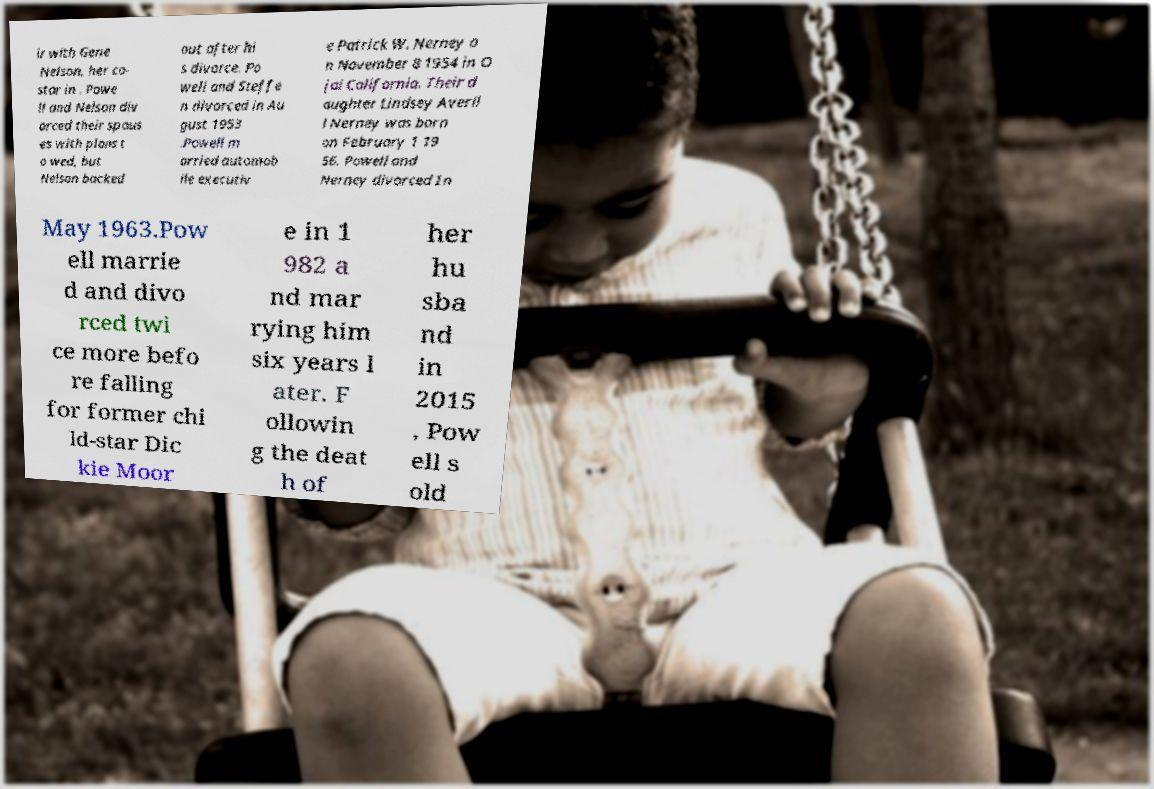Please identify and transcribe the text found in this image. ir with Gene Nelson, her co- star in . Powe ll and Nelson div orced their spous es with plans t o wed, but Nelson backed out after hi s divorce. Po well and Steffe n divorced in Au gust 1953 .Powell m arried automob ile executiv e Patrick W. Nerney o n November 8 1954 in O jai California. Their d aughter Lindsey Averil l Nerney was born on February 1 19 56. Powell and Nerney divorced In May 1963.Pow ell marrie d and divo rced twi ce more befo re falling for former chi ld-star Dic kie Moor e in 1 982 a nd mar rying him six years l ater. F ollowin g the deat h of her hu sba nd in 2015 , Pow ell s old 